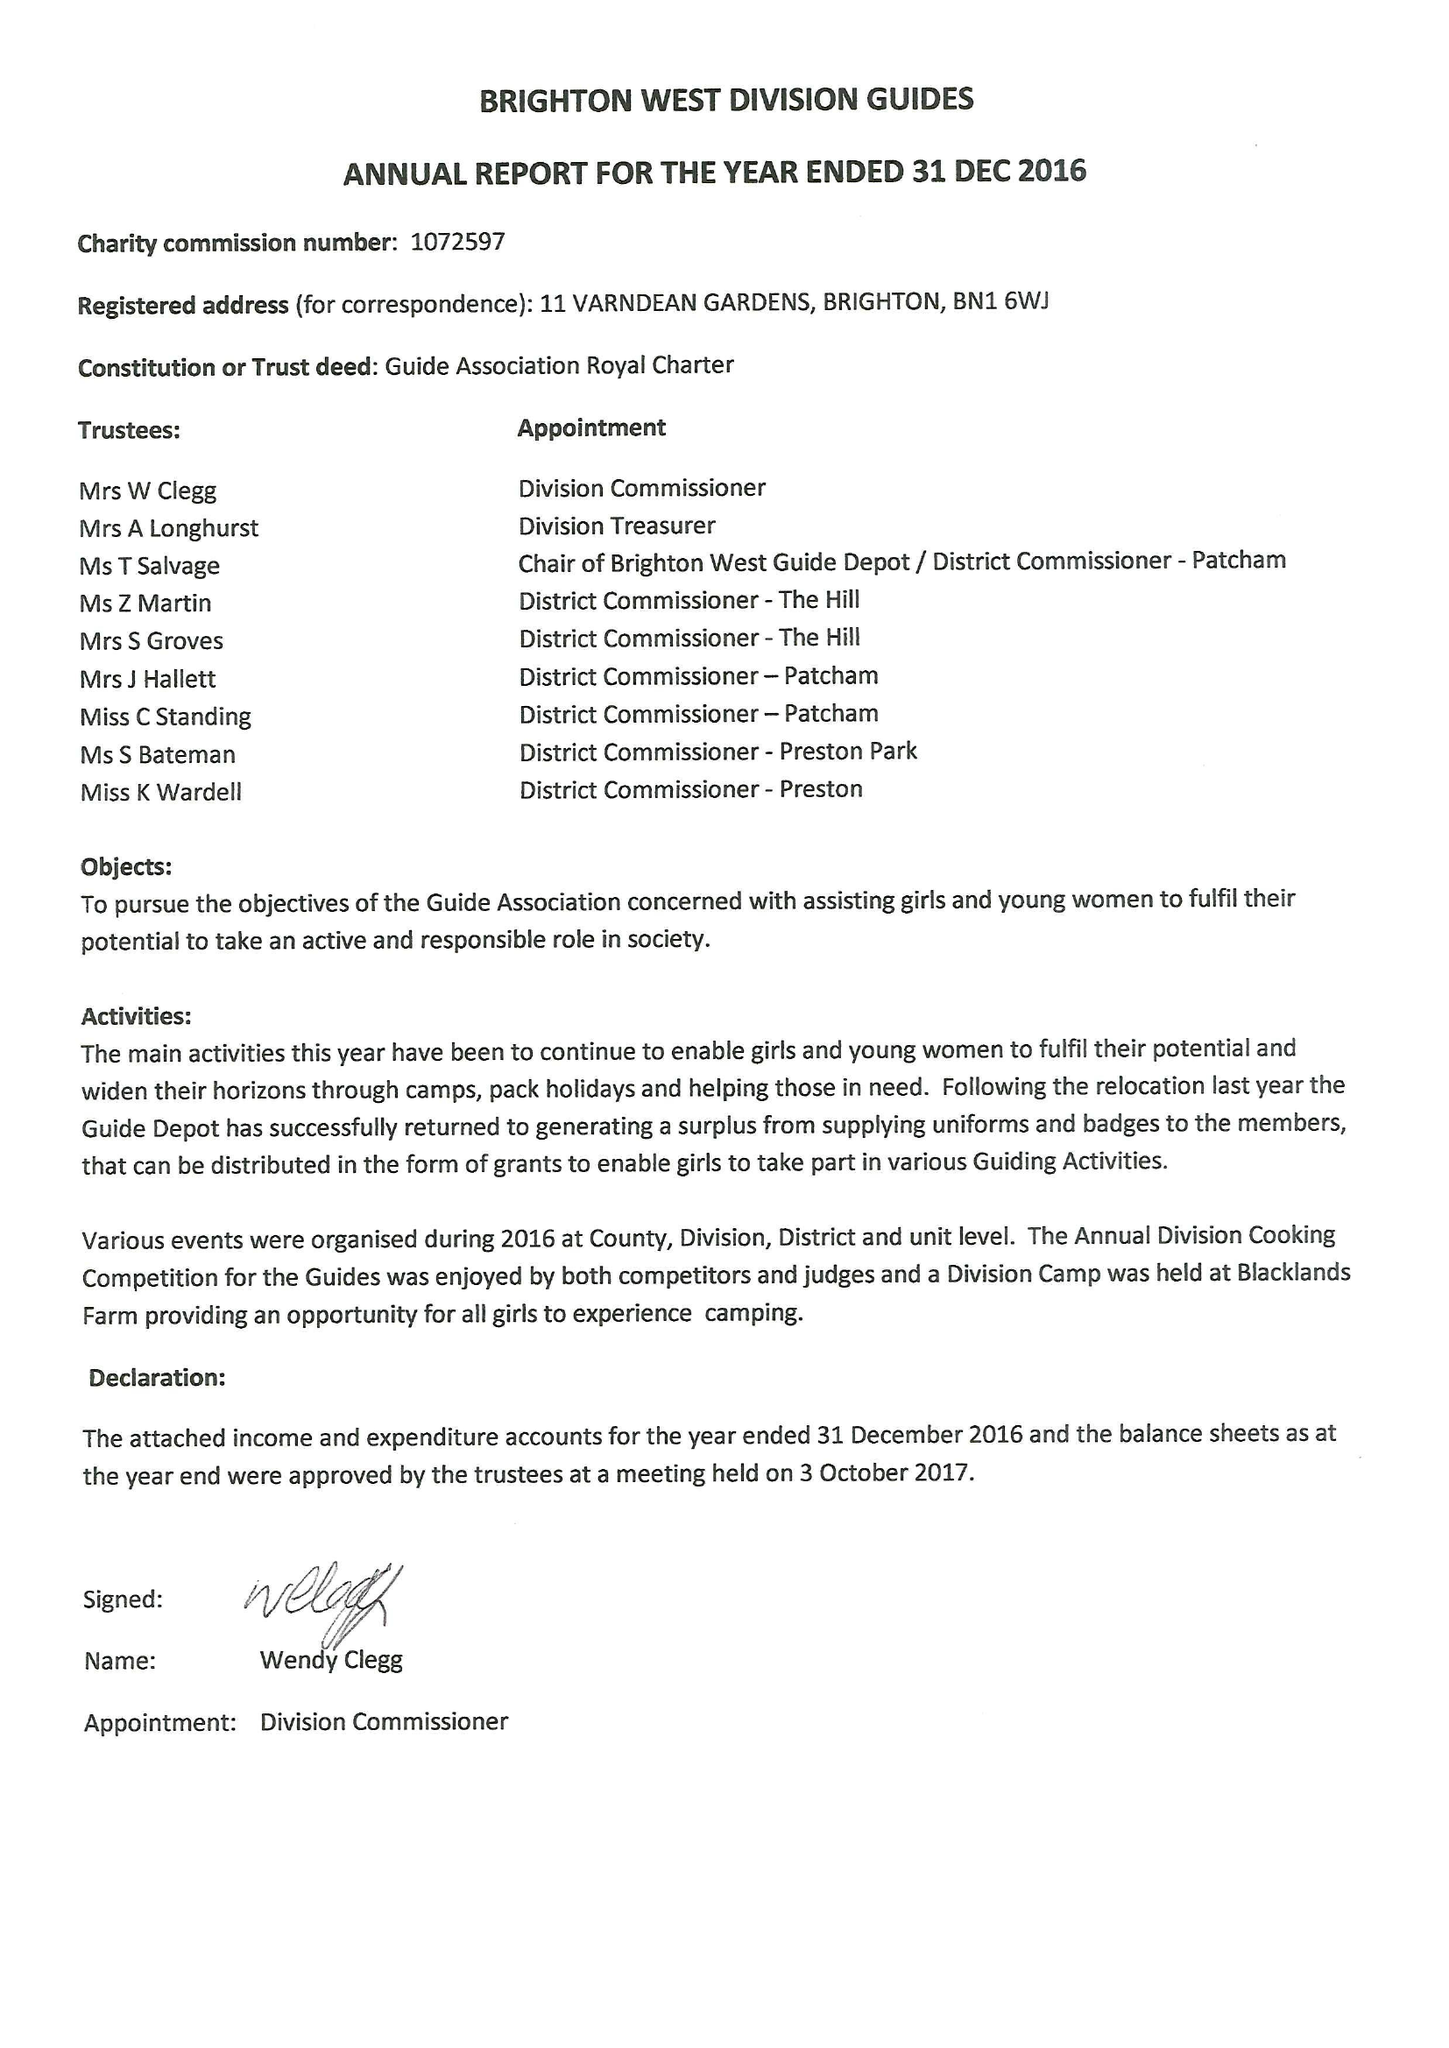What is the value for the address__street_line?
Answer the question using a single word or phrase. 11 VARNDEAN GARDENS 